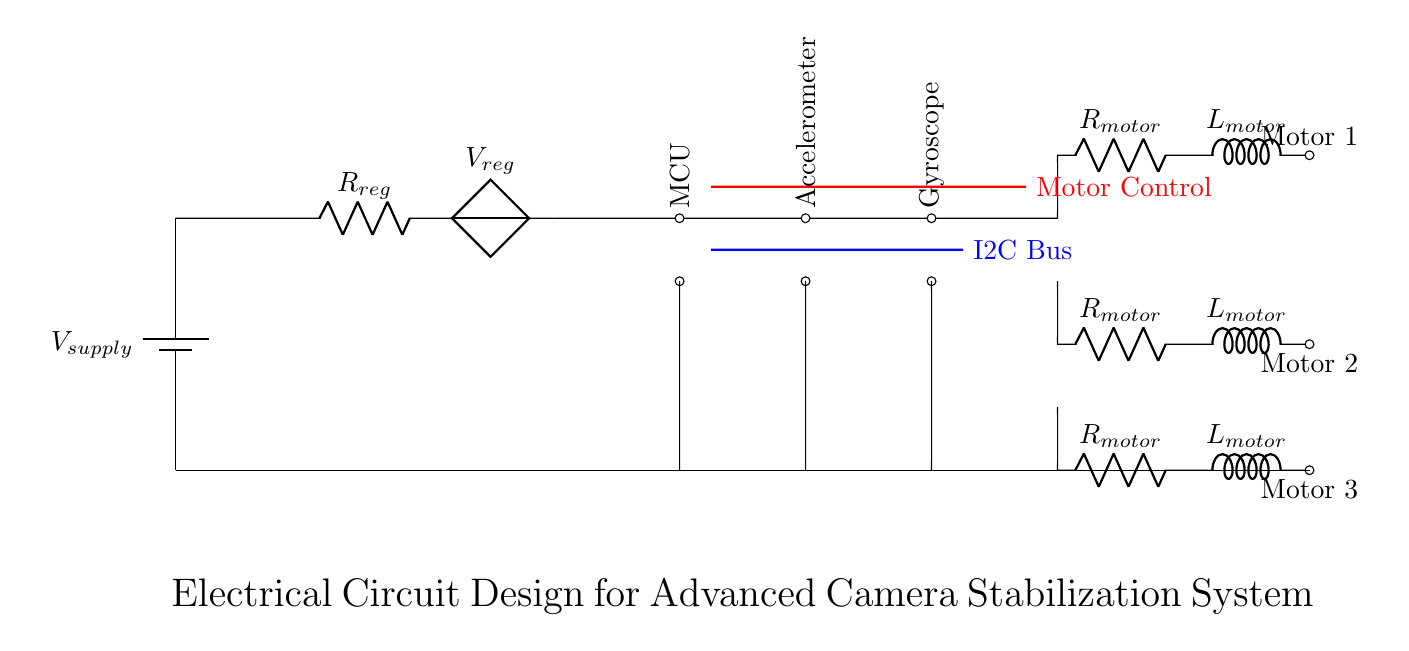What is the component type used for power supply? The power supply component type is a battery, as indicated by the symbol.
Answer: battery What is the function of the voltage regulator in this circuit? The voltage regulator ensures a stable output voltage for the components by regulating the supply voltage.
Answer: regulation Which microcontroller component is present in the circuit? The microcontroller component is labeled as MCU and includes connections for power and ground.
Answer: MCU How many motors are controlled in this circuit? There are three motors connected to the motor drivers, as shown by the motor symbols in the diagram.
Answer: three What is the purpose of the I2C bus in this circuit? The I2C bus facilitates communication between the microcontroller and other components like the accelerometer and gyroscope.
Answer: communication What can be inferred about the grounding in this circuit? The circuit has a common ground where all components connect to ensure proper operation and safety.
Answer: common ground Which sensor types are included in the circuit? The circuit includes two sensors: an accelerometer and a gyroscope for motion detection.
Answer: accelerometer and gyroscope 